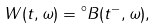Convert formula to latex. <formula><loc_0><loc_0><loc_500><loc_500>W ( t , \omega ) = { ^ { \circ } B } ( t ^ { - } , \omega ) ,</formula> 